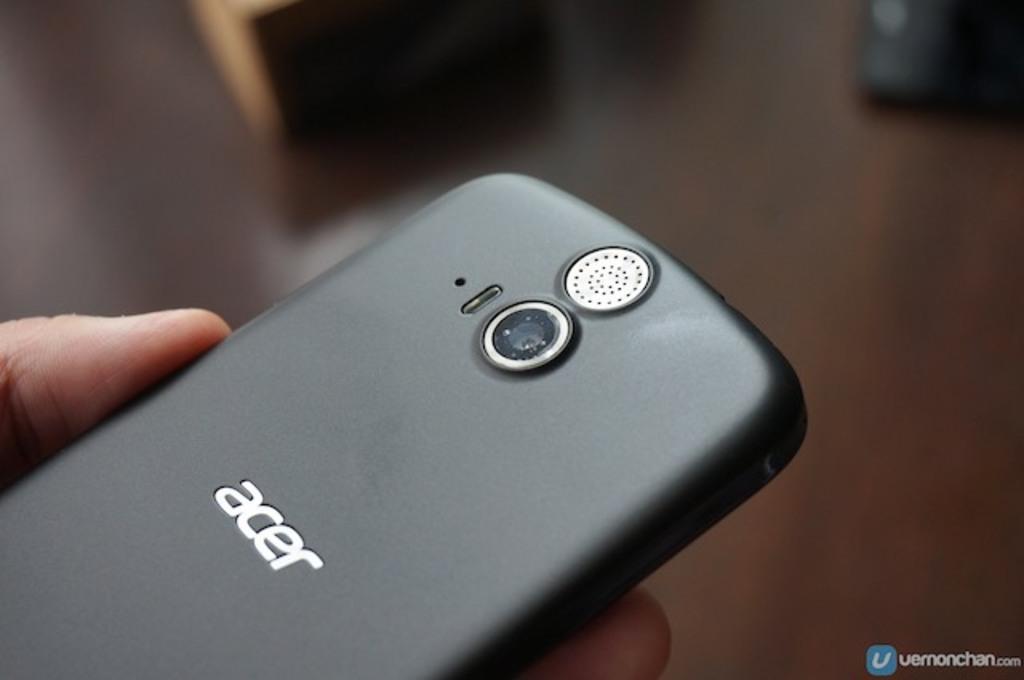Can you describe this image briefly? In this picture we can see a person holding a mobile and in the background we can see some objects and it is blurry, in the bottom right we can see some text on it. 